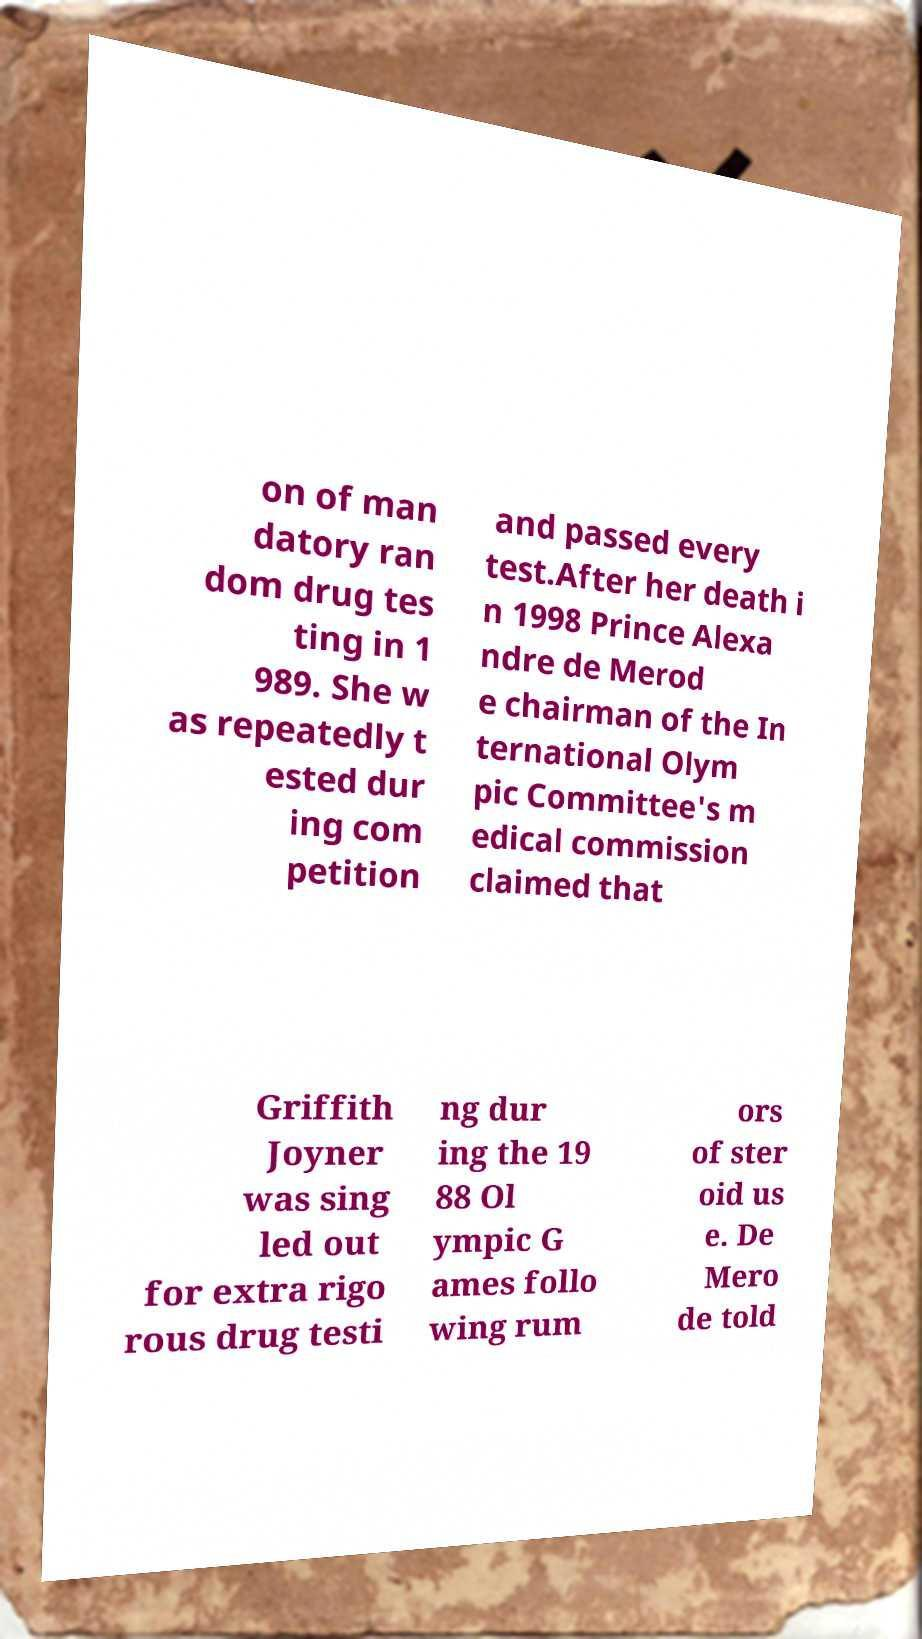Could you assist in decoding the text presented in this image and type it out clearly? on of man datory ran dom drug tes ting in 1 989. She w as repeatedly t ested dur ing com petition and passed every test.After her death i n 1998 Prince Alexa ndre de Merod e chairman of the In ternational Olym pic Committee's m edical commission claimed that Griffith Joyner was sing led out for extra rigo rous drug testi ng dur ing the 19 88 Ol ympic G ames follo wing rum ors of ster oid us e. De Mero de told 